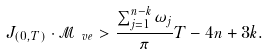Convert formula to latex. <formula><loc_0><loc_0><loc_500><loc_500>J _ { ( 0 , T ) } \cdot \mathcal { M } _ { \ v e } > \frac { \sum _ { j = 1 } ^ { n - k } \omega _ { j } } { \pi } T - 4 n + 3 k .</formula> 